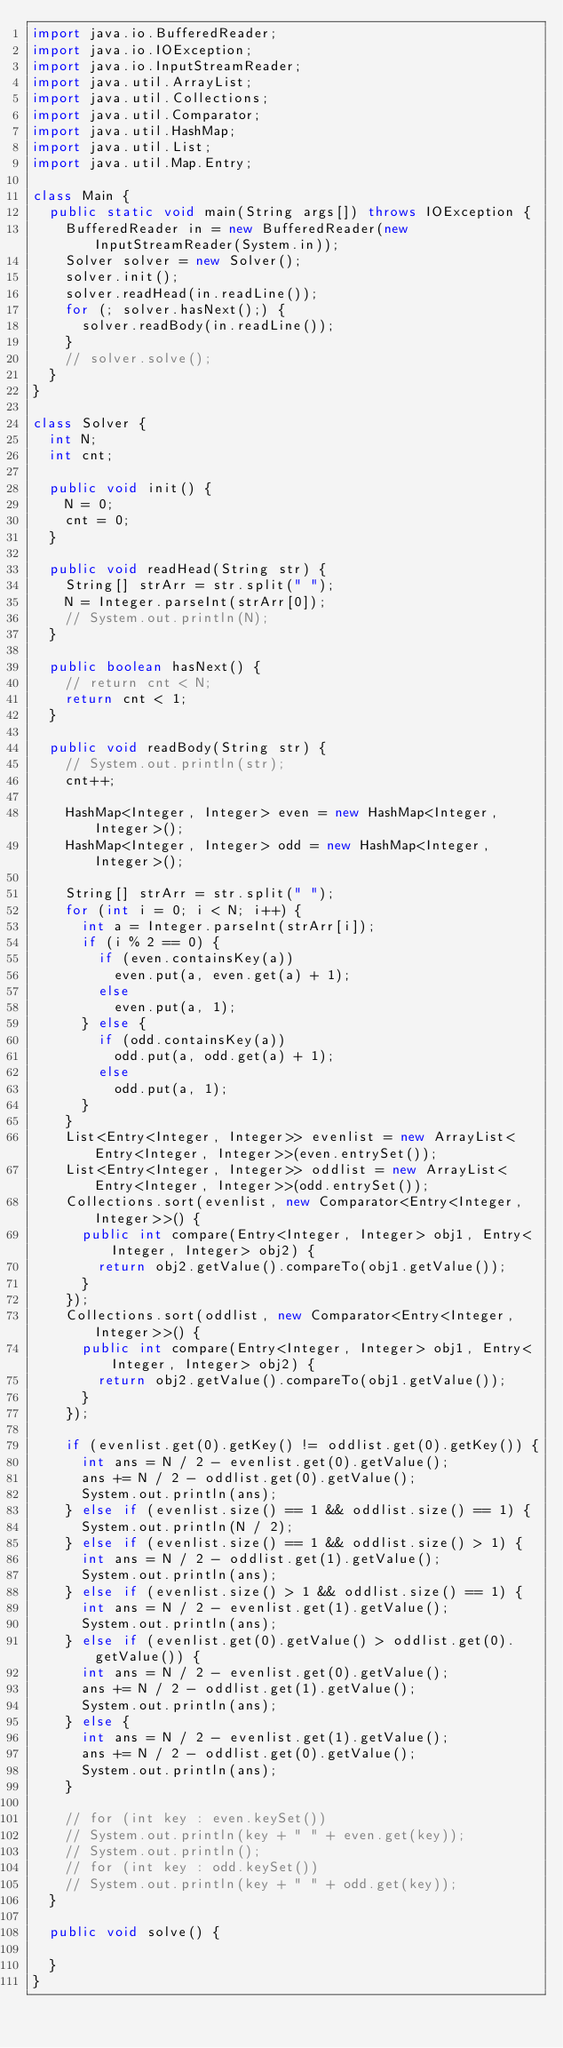<code> <loc_0><loc_0><loc_500><loc_500><_Java_>import java.io.BufferedReader;
import java.io.IOException;
import java.io.InputStreamReader;
import java.util.ArrayList;
import java.util.Collections;
import java.util.Comparator;
import java.util.HashMap;
import java.util.List;
import java.util.Map.Entry;

class Main {
	public static void main(String args[]) throws IOException {
		BufferedReader in = new BufferedReader(new InputStreamReader(System.in));
		Solver solver = new Solver();
		solver.init();
		solver.readHead(in.readLine());
		for (; solver.hasNext();) {
			solver.readBody(in.readLine());
		}
		// solver.solve();
	}
}

class Solver {
	int N;
	int cnt;

	public void init() {
		N = 0;
		cnt = 0;
	}

	public void readHead(String str) {
		String[] strArr = str.split(" ");
		N = Integer.parseInt(strArr[0]);
		// System.out.println(N);
	}

	public boolean hasNext() {
		// return cnt < N;
		return cnt < 1;
	}

	public void readBody(String str) {
		// System.out.println(str);
		cnt++;

		HashMap<Integer, Integer> even = new HashMap<Integer, Integer>();
		HashMap<Integer, Integer> odd = new HashMap<Integer, Integer>();

		String[] strArr = str.split(" ");
		for (int i = 0; i < N; i++) {
			int a = Integer.parseInt(strArr[i]);
			if (i % 2 == 0) {
				if (even.containsKey(a))
					even.put(a, even.get(a) + 1);
				else
					even.put(a, 1);
			} else {
				if (odd.containsKey(a))
					odd.put(a, odd.get(a) + 1);
				else
					odd.put(a, 1);
			}
		}
		List<Entry<Integer, Integer>> evenlist = new ArrayList<Entry<Integer, Integer>>(even.entrySet());
		List<Entry<Integer, Integer>> oddlist = new ArrayList<Entry<Integer, Integer>>(odd.entrySet());
		Collections.sort(evenlist, new Comparator<Entry<Integer, Integer>>() {
			public int compare(Entry<Integer, Integer> obj1, Entry<Integer, Integer> obj2) {
				return obj2.getValue().compareTo(obj1.getValue());
			}
		});
		Collections.sort(oddlist, new Comparator<Entry<Integer, Integer>>() {
			public int compare(Entry<Integer, Integer> obj1, Entry<Integer, Integer> obj2) {
				return obj2.getValue().compareTo(obj1.getValue());
			}
		});

		if (evenlist.get(0).getKey() != oddlist.get(0).getKey()) {
			int ans = N / 2 - evenlist.get(0).getValue();
			ans += N / 2 - oddlist.get(0).getValue();
			System.out.println(ans);
		} else if (evenlist.size() == 1 && oddlist.size() == 1) {
			System.out.println(N / 2);
		} else if (evenlist.size() == 1 && oddlist.size() > 1) {
			int ans = N / 2 - oddlist.get(1).getValue();
			System.out.println(ans);
		} else if (evenlist.size() > 1 && oddlist.size() == 1) {
			int ans = N / 2 - evenlist.get(1).getValue();
			System.out.println(ans);
		} else if (evenlist.get(0).getValue() > oddlist.get(0).getValue()) {
			int ans = N / 2 - evenlist.get(0).getValue();
			ans += N / 2 - oddlist.get(1).getValue();
			System.out.println(ans);
		} else {
			int ans = N / 2 - evenlist.get(1).getValue();
			ans += N / 2 - oddlist.get(0).getValue();
			System.out.println(ans);
		}

		// for (int key : even.keySet())
		// System.out.println(key + " " + even.get(key));
		// System.out.println();
		// for (int key : odd.keySet())
		// System.out.println(key + " " + odd.get(key));
	}

	public void solve() {

	}
}
</code> 